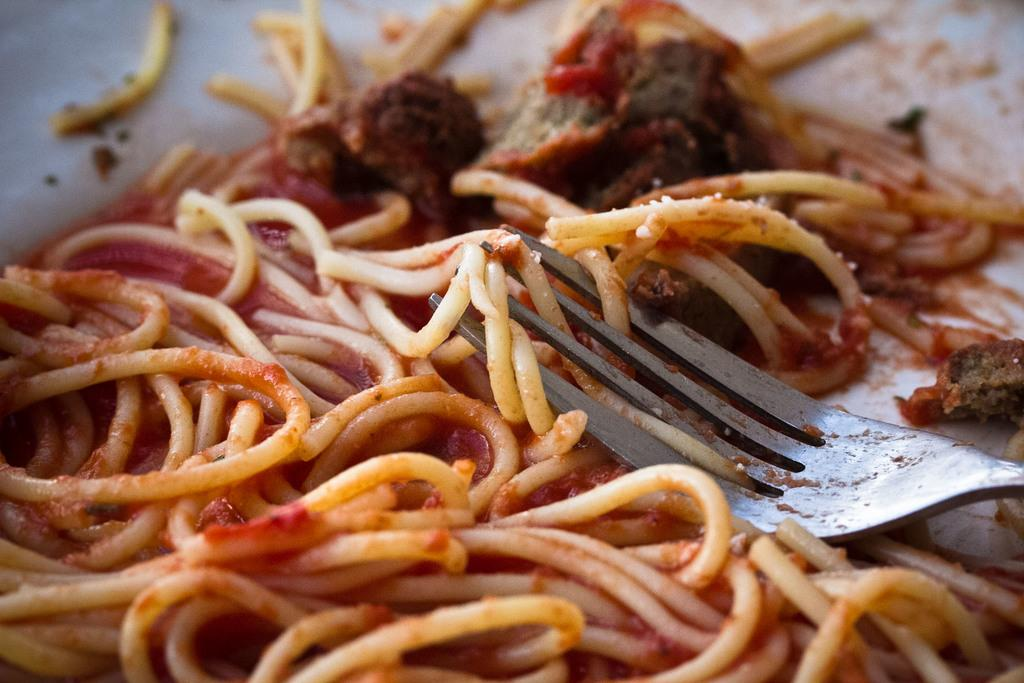What type of food is visible in the image? There are noodles in the image. What utensil is present in the image? There is a fork in the image, located towards the right. What type of match is being played in the image? There is no match or game visible in the image; it only features noodles and a fork. How many heads can be seen in the image? There are no heads or people visible in the image. 